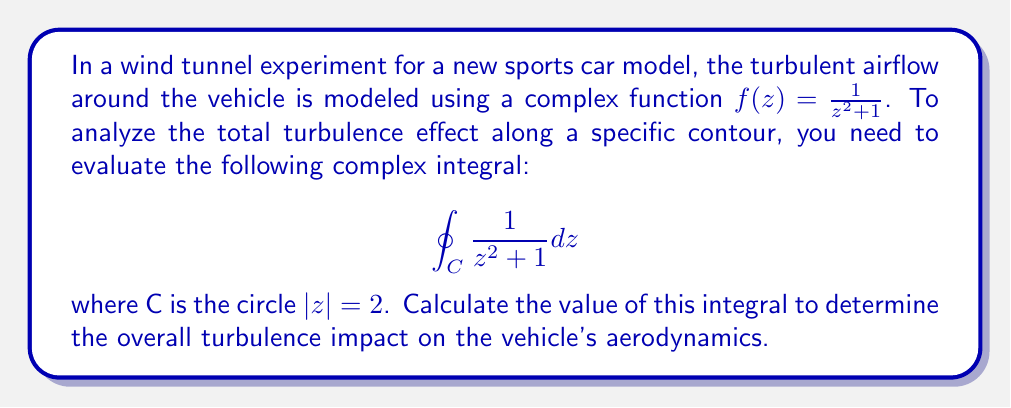Can you solve this math problem? To evaluate this complex integral, we'll use the Residue Theorem. The steps are as follows:

1) First, identify the singularities of the function $f(z) = \frac{1}{z^2 + 1}$ inside the contour C.
   The singularities occur when $z^2 + 1 = 0$, i.e., when $z = \pm i$.
   Only $z = i$ lies inside the contour $|z| = 2$.

2) Calculate the residue at $z = i$:
   $$\text{Res}(f, i) = \lim_{z \to i} (z-i)\frac{1}{z^2 + 1}$$
   
   To evaluate this limit, let $z = i + h$:
   $$\lim_{h \to 0} h\frac{1}{(i+h)^2 + 1} = \lim_{h \to 0} h\frac{1}{i^2 + 2ih - h^2 + 1}$$
   $$= \lim_{h \to 0} h\frac{1}{2ih - h^2} = \lim_{h \to 0} \frac{1}{2i - h} = \frac{1}{2i}$$

3) Apply the Residue Theorem:
   $$\oint_C f(z)dz = 2\pi i \sum \text{Res}(f, a_k)$$
   where $a_k$ are the singularities inside C.

   In this case, we have only one singularity inside C, so:
   $$\oint_C \frac{1}{z^2 + 1} dz = 2\pi i \cdot \frac{1}{2i} = \pi$$

Therefore, the value of the integral is $\pi$.
Answer: $\pi$ 